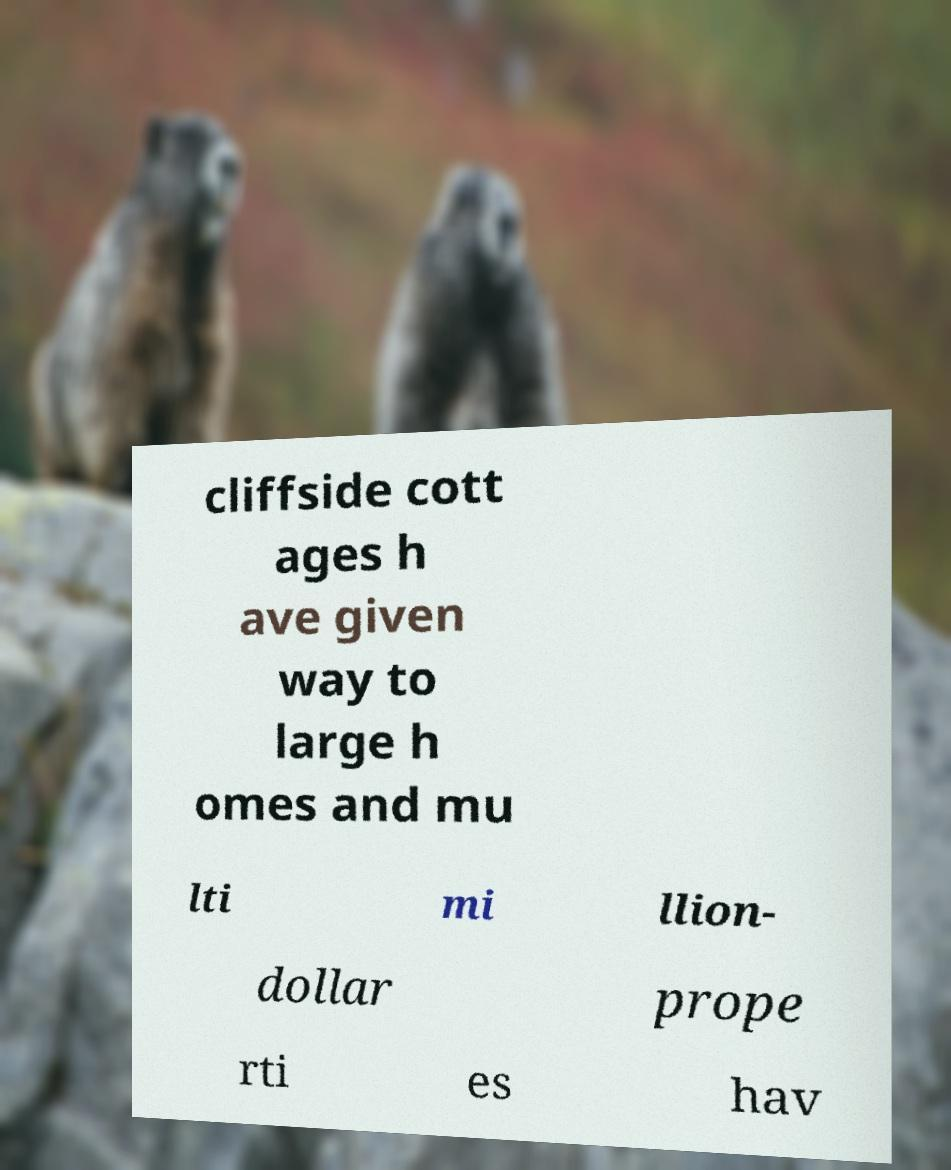Could you assist in decoding the text presented in this image and type it out clearly? cliffside cott ages h ave given way to large h omes and mu lti mi llion- dollar prope rti es hav 